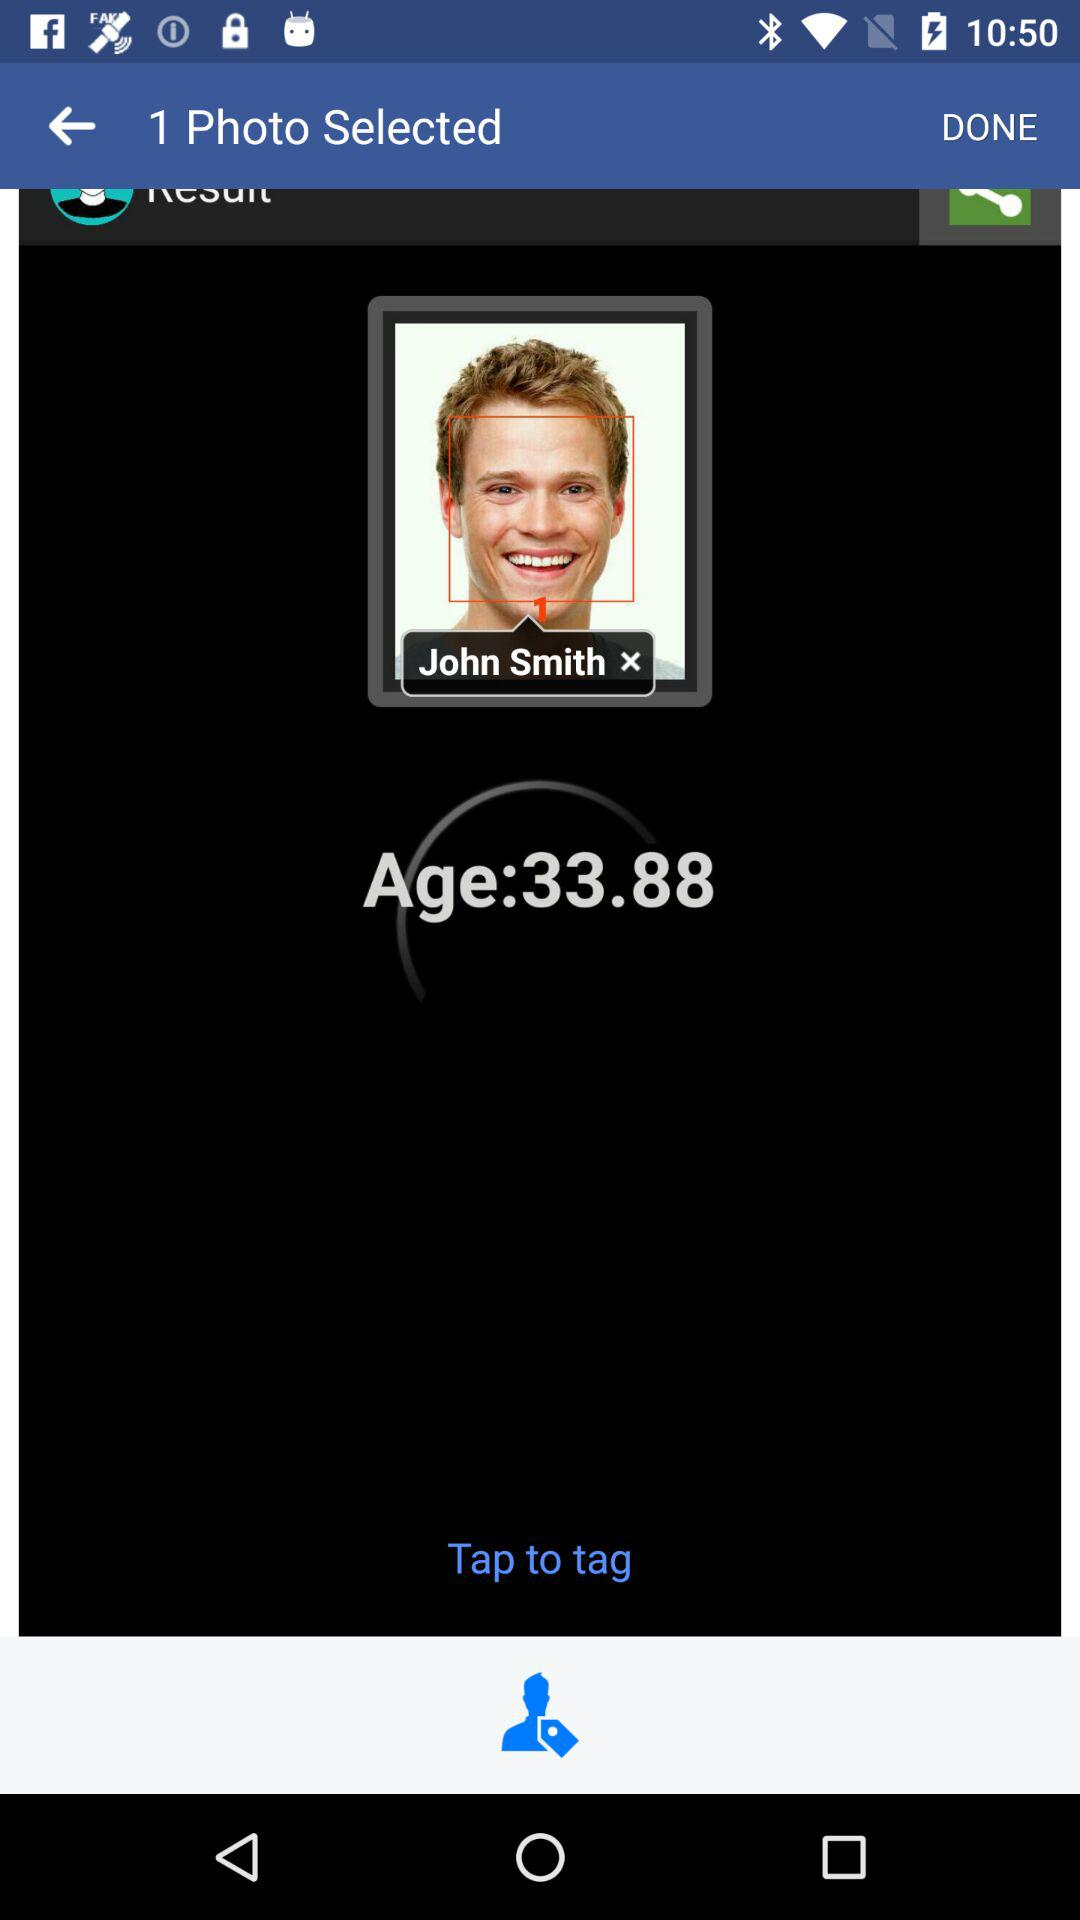What is the age of John Smith? The age of John Smith is 33.88. 